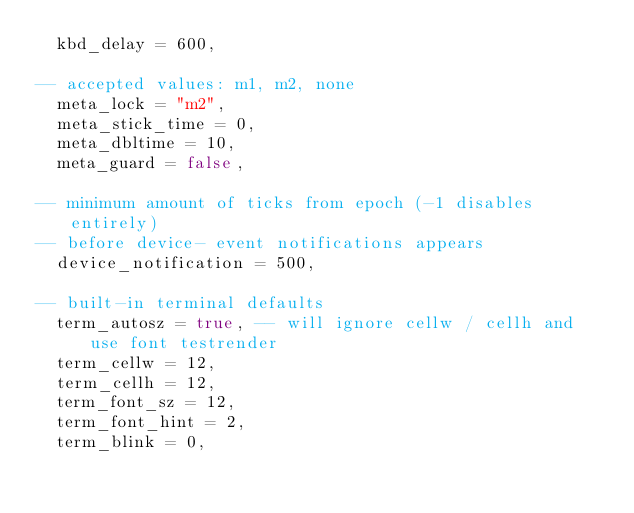<code> <loc_0><loc_0><loc_500><loc_500><_Lua_>	kbd_delay = 600,

-- accepted values: m1, m2, none
	meta_lock = "m2",
	meta_stick_time = 0,
	meta_dbltime = 10,
	meta_guard = false,

-- minimum amount of ticks from epoch (-1 disables entirely)
-- before device- event notifications appears
	device_notification = 500,

-- built-in terminal defaults
	term_autosz = true, -- will ignore cellw / cellh and use font testrender
	term_cellw = 12,
	term_cellh = 12,
	term_font_sz = 12,
	term_font_hint = 2,
	term_blink = 0,</code> 